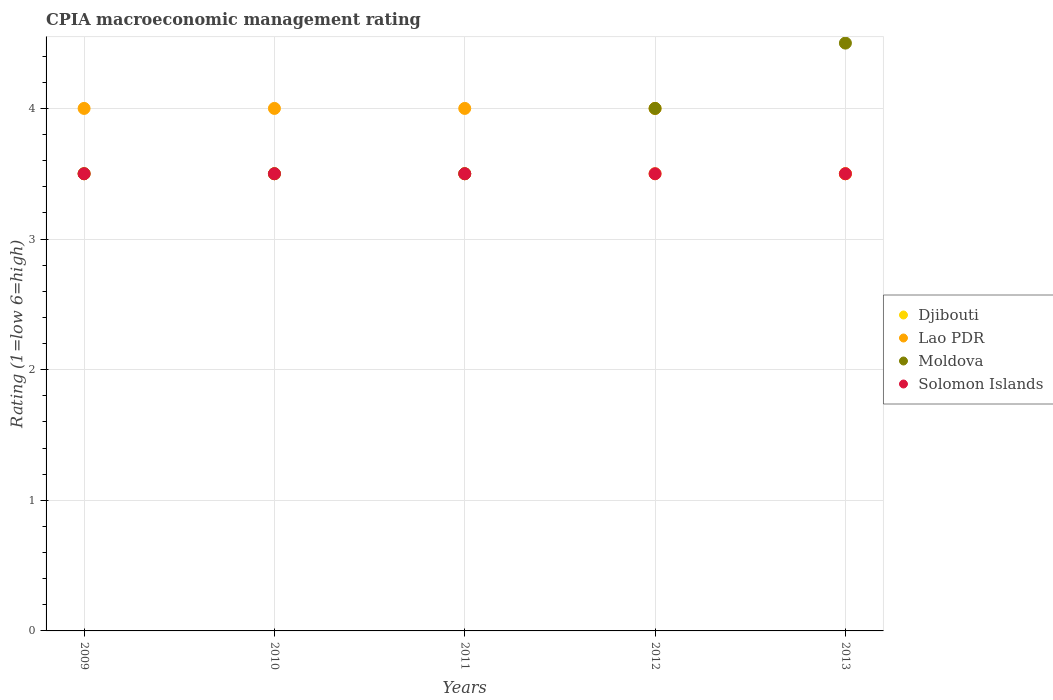Is the number of dotlines equal to the number of legend labels?
Provide a succinct answer. Yes. Across all years, what is the minimum CPIA rating in Solomon Islands?
Make the answer very short. 3.5. In which year was the CPIA rating in Djibouti maximum?
Give a very brief answer. 2009. What is the difference between the CPIA rating in Moldova in 2011 and the CPIA rating in Solomon Islands in 2012?
Make the answer very short. 0. What is the average CPIA rating in Solomon Islands per year?
Ensure brevity in your answer.  3.5. What is the ratio of the CPIA rating in Djibouti in 2012 to that in 2013?
Make the answer very short. 1. Is the CPIA rating in Lao PDR in 2009 less than that in 2013?
Make the answer very short. No. Is the difference between the CPIA rating in Djibouti in 2009 and 2010 greater than the difference between the CPIA rating in Moldova in 2009 and 2010?
Keep it short and to the point. No. What is the difference between the highest and the second highest CPIA rating in Djibouti?
Offer a very short reply. 0. Is it the case that in every year, the sum of the CPIA rating in Moldova and CPIA rating in Lao PDR  is greater than the sum of CPIA rating in Solomon Islands and CPIA rating in Djibouti?
Offer a terse response. Yes. Is it the case that in every year, the sum of the CPIA rating in Lao PDR and CPIA rating in Djibouti  is greater than the CPIA rating in Solomon Islands?
Give a very brief answer. Yes. How many dotlines are there?
Your response must be concise. 4. What is the difference between two consecutive major ticks on the Y-axis?
Provide a succinct answer. 1. Are the values on the major ticks of Y-axis written in scientific E-notation?
Offer a terse response. No. Where does the legend appear in the graph?
Offer a terse response. Center right. How many legend labels are there?
Provide a succinct answer. 4. How are the legend labels stacked?
Your answer should be very brief. Vertical. What is the title of the graph?
Provide a short and direct response. CPIA macroeconomic management rating. What is the label or title of the X-axis?
Ensure brevity in your answer.  Years. What is the label or title of the Y-axis?
Provide a short and direct response. Rating (1=low 6=high). What is the Rating (1=low 6=high) in Lao PDR in 2009?
Provide a succinct answer. 4. What is the Rating (1=low 6=high) in Solomon Islands in 2009?
Give a very brief answer. 3.5. What is the Rating (1=low 6=high) of Moldova in 2010?
Give a very brief answer. 3.5. What is the Rating (1=low 6=high) in Djibouti in 2011?
Provide a succinct answer. 3.5. What is the Rating (1=low 6=high) in Moldova in 2011?
Provide a short and direct response. 3.5. What is the Rating (1=low 6=high) of Solomon Islands in 2011?
Ensure brevity in your answer.  3.5. What is the Rating (1=low 6=high) of Djibouti in 2012?
Give a very brief answer. 3.5. What is the Rating (1=low 6=high) of Lao PDR in 2012?
Offer a very short reply. 4. What is the Rating (1=low 6=high) of Moldova in 2012?
Offer a very short reply. 4. What is the Rating (1=low 6=high) of Solomon Islands in 2012?
Keep it short and to the point. 3.5. What is the Rating (1=low 6=high) of Djibouti in 2013?
Your answer should be compact. 3.5. What is the Rating (1=low 6=high) of Solomon Islands in 2013?
Ensure brevity in your answer.  3.5. Across all years, what is the maximum Rating (1=low 6=high) in Djibouti?
Keep it short and to the point. 3.5. Across all years, what is the maximum Rating (1=low 6=high) of Lao PDR?
Provide a succinct answer. 4. Across all years, what is the maximum Rating (1=low 6=high) of Solomon Islands?
Provide a short and direct response. 3.5. Across all years, what is the minimum Rating (1=low 6=high) in Moldova?
Your answer should be compact. 3.5. Across all years, what is the minimum Rating (1=low 6=high) in Solomon Islands?
Offer a very short reply. 3.5. What is the total Rating (1=low 6=high) of Lao PDR in the graph?
Ensure brevity in your answer.  19.5. What is the total Rating (1=low 6=high) in Solomon Islands in the graph?
Give a very brief answer. 17.5. What is the difference between the Rating (1=low 6=high) of Djibouti in 2009 and that in 2010?
Your response must be concise. 0. What is the difference between the Rating (1=low 6=high) of Lao PDR in 2009 and that in 2010?
Provide a short and direct response. 0. What is the difference between the Rating (1=low 6=high) in Djibouti in 2009 and that in 2011?
Provide a succinct answer. 0. What is the difference between the Rating (1=low 6=high) in Lao PDR in 2009 and that in 2011?
Make the answer very short. 0. What is the difference between the Rating (1=low 6=high) of Moldova in 2009 and that in 2011?
Your answer should be very brief. 0. What is the difference between the Rating (1=low 6=high) in Moldova in 2009 and that in 2012?
Make the answer very short. -0.5. What is the difference between the Rating (1=low 6=high) in Solomon Islands in 2009 and that in 2012?
Offer a very short reply. 0. What is the difference between the Rating (1=low 6=high) in Djibouti in 2009 and that in 2013?
Provide a short and direct response. 0. What is the difference between the Rating (1=low 6=high) in Lao PDR in 2009 and that in 2013?
Offer a very short reply. 0.5. What is the difference between the Rating (1=low 6=high) of Moldova in 2009 and that in 2013?
Provide a succinct answer. -1. What is the difference between the Rating (1=low 6=high) of Solomon Islands in 2009 and that in 2013?
Offer a terse response. 0. What is the difference between the Rating (1=low 6=high) of Lao PDR in 2010 and that in 2011?
Provide a succinct answer. 0. What is the difference between the Rating (1=low 6=high) in Moldova in 2010 and that in 2012?
Ensure brevity in your answer.  -0.5. What is the difference between the Rating (1=low 6=high) in Djibouti in 2010 and that in 2013?
Make the answer very short. 0. What is the difference between the Rating (1=low 6=high) in Lao PDR in 2010 and that in 2013?
Keep it short and to the point. 0.5. What is the difference between the Rating (1=low 6=high) in Moldova in 2011 and that in 2012?
Give a very brief answer. -0.5. What is the difference between the Rating (1=low 6=high) in Lao PDR in 2011 and that in 2013?
Your response must be concise. 0.5. What is the difference between the Rating (1=low 6=high) of Moldova in 2012 and that in 2013?
Your response must be concise. -0.5. What is the difference between the Rating (1=low 6=high) in Solomon Islands in 2012 and that in 2013?
Keep it short and to the point. 0. What is the difference between the Rating (1=low 6=high) in Djibouti in 2009 and the Rating (1=low 6=high) in Moldova in 2010?
Make the answer very short. 0. What is the difference between the Rating (1=low 6=high) in Djibouti in 2009 and the Rating (1=low 6=high) in Lao PDR in 2011?
Your answer should be very brief. -0.5. What is the difference between the Rating (1=low 6=high) of Djibouti in 2009 and the Rating (1=low 6=high) of Moldova in 2011?
Give a very brief answer. 0. What is the difference between the Rating (1=low 6=high) of Lao PDR in 2009 and the Rating (1=low 6=high) of Moldova in 2011?
Provide a short and direct response. 0.5. What is the difference between the Rating (1=low 6=high) of Lao PDR in 2009 and the Rating (1=low 6=high) of Solomon Islands in 2011?
Give a very brief answer. 0.5. What is the difference between the Rating (1=low 6=high) in Moldova in 2009 and the Rating (1=low 6=high) in Solomon Islands in 2011?
Give a very brief answer. 0. What is the difference between the Rating (1=low 6=high) of Djibouti in 2009 and the Rating (1=low 6=high) of Moldova in 2012?
Make the answer very short. -0.5. What is the difference between the Rating (1=low 6=high) of Djibouti in 2009 and the Rating (1=low 6=high) of Solomon Islands in 2012?
Provide a short and direct response. 0. What is the difference between the Rating (1=low 6=high) of Lao PDR in 2009 and the Rating (1=low 6=high) of Moldova in 2012?
Your response must be concise. 0. What is the difference between the Rating (1=low 6=high) of Djibouti in 2009 and the Rating (1=low 6=high) of Moldova in 2013?
Your answer should be compact. -1. What is the difference between the Rating (1=low 6=high) of Lao PDR in 2009 and the Rating (1=low 6=high) of Moldova in 2013?
Give a very brief answer. -0.5. What is the difference between the Rating (1=low 6=high) in Djibouti in 2010 and the Rating (1=low 6=high) in Lao PDR in 2011?
Your answer should be compact. -0.5. What is the difference between the Rating (1=low 6=high) in Djibouti in 2010 and the Rating (1=low 6=high) in Moldova in 2011?
Ensure brevity in your answer.  0. What is the difference between the Rating (1=low 6=high) of Djibouti in 2010 and the Rating (1=low 6=high) of Solomon Islands in 2011?
Offer a terse response. 0. What is the difference between the Rating (1=low 6=high) in Moldova in 2010 and the Rating (1=low 6=high) in Solomon Islands in 2011?
Offer a terse response. 0. What is the difference between the Rating (1=low 6=high) in Djibouti in 2010 and the Rating (1=low 6=high) in Moldova in 2012?
Your response must be concise. -0.5. What is the difference between the Rating (1=low 6=high) of Lao PDR in 2010 and the Rating (1=low 6=high) of Solomon Islands in 2012?
Offer a terse response. 0.5. What is the difference between the Rating (1=low 6=high) of Djibouti in 2010 and the Rating (1=low 6=high) of Solomon Islands in 2013?
Make the answer very short. 0. What is the difference between the Rating (1=low 6=high) of Moldova in 2010 and the Rating (1=low 6=high) of Solomon Islands in 2013?
Provide a short and direct response. 0. What is the difference between the Rating (1=low 6=high) of Djibouti in 2011 and the Rating (1=low 6=high) of Lao PDR in 2012?
Provide a succinct answer. -0.5. What is the difference between the Rating (1=low 6=high) in Lao PDR in 2011 and the Rating (1=low 6=high) in Moldova in 2012?
Ensure brevity in your answer.  0. What is the difference between the Rating (1=low 6=high) in Lao PDR in 2011 and the Rating (1=low 6=high) in Solomon Islands in 2012?
Your response must be concise. 0.5. What is the difference between the Rating (1=low 6=high) of Djibouti in 2011 and the Rating (1=low 6=high) of Lao PDR in 2013?
Keep it short and to the point. 0. What is the difference between the Rating (1=low 6=high) of Djibouti in 2011 and the Rating (1=low 6=high) of Moldova in 2013?
Your answer should be compact. -1. What is the difference between the Rating (1=low 6=high) of Djibouti in 2011 and the Rating (1=low 6=high) of Solomon Islands in 2013?
Ensure brevity in your answer.  0. What is the difference between the Rating (1=low 6=high) in Lao PDR in 2011 and the Rating (1=low 6=high) in Moldova in 2013?
Offer a terse response. -0.5. What is the difference between the Rating (1=low 6=high) of Djibouti in 2012 and the Rating (1=low 6=high) of Solomon Islands in 2013?
Keep it short and to the point. 0. What is the average Rating (1=low 6=high) of Djibouti per year?
Provide a short and direct response. 3.5. What is the average Rating (1=low 6=high) in Lao PDR per year?
Provide a short and direct response. 3.9. What is the average Rating (1=low 6=high) in Moldova per year?
Offer a very short reply. 3.8. In the year 2009, what is the difference between the Rating (1=low 6=high) of Djibouti and Rating (1=low 6=high) of Solomon Islands?
Provide a succinct answer. 0. In the year 2009, what is the difference between the Rating (1=low 6=high) of Lao PDR and Rating (1=low 6=high) of Solomon Islands?
Keep it short and to the point. 0.5. In the year 2009, what is the difference between the Rating (1=low 6=high) in Moldova and Rating (1=low 6=high) in Solomon Islands?
Make the answer very short. 0. In the year 2010, what is the difference between the Rating (1=low 6=high) of Djibouti and Rating (1=low 6=high) of Lao PDR?
Offer a very short reply. -0.5. In the year 2010, what is the difference between the Rating (1=low 6=high) in Djibouti and Rating (1=low 6=high) in Solomon Islands?
Provide a short and direct response. 0. In the year 2010, what is the difference between the Rating (1=low 6=high) in Lao PDR and Rating (1=low 6=high) in Moldova?
Offer a terse response. 0.5. In the year 2011, what is the difference between the Rating (1=low 6=high) in Djibouti and Rating (1=low 6=high) in Moldova?
Provide a succinct answer. 0. In the year 2011, what is the difference between the Rating (1=low 6=high) of Lao PDR and Rating (1=low 6=high) of Solomon Islands?
Provide a short and direct response. 0.5. In the year 2012, what is the difference between the Rating (1=low 6=high) of Djibouti and Rating (1=low 6=high) of Moldova?
Your answer should be very brief. -0.5. In the year 2012, what is the difference between the Rating (1=low 6=high) in Lao PDR and Rating (1=low 6=high) in Solomon Islands?
Your response must be concise. 0.5. In the year 2013, what is the difference between the Rating (1=low 6=high) in Djibouti and Rating (1=low 6=high) in Moldova?
Keep it short and to the point. -1. In the year 2013, what is the difference between the Rating (1=low 6=high) in Djibouti and Rating (1=low 6=high) in Solomon Islands?
Make the answer very short. 0. In the year 2013, what is the difference between the Rating (1=low 6=high) in Lao PDR and Rating (1=low 6=high) in Solomon Islands?
Offer a very short reply. 0. What is the ratio of the Rating (1=low 6=high) in Djibouti in 2009 to that in 2010?
Provide a short and direct response. 1. What is the ratio of the Rating (1=low 6=high) in Djibouti in 2009 to that in 2012?
Make the answer very short. 1. What is the ratio of the Rating (1=low 6=high) of Lao PDR in 2009 to that in 2012?
Your response must be concise. 1. What is the ratio of the Rating (1=low 6=high) of Moldova in 2009 to that in 2012?
Give a very brief answer. 0.88. What is the ratio of the Rating (1=low 6=high) of Djibouti in 2009 to that in 2013?
Keep it short and to the point. 1. What is the ratio of the Rating (1=low 6=high) of Lao PDR in 2009 to that in 2013?
Your answer should be compact. 1.14. What is the ratio of the Rating (1=low 6=high) in Solomon Islands in 2009 to that in 2013?
Provide a succinct answer. 1. What is the ratio of the Rating (1=low 6=high) in Djibouti in 2010 to that in 2011?
Your response must be concise. 1. What is the ratio of the Rating (1=low 6=high) in Lao PDR in 2010 to that in 2012?
Give a very brief answer. 1. What is the ratio of the Rating (1=low 6=high) of Djibouti in 2010 to that in 2013?
Provide a succinct answer. 1. What is the ratio of the Rating (1=low 6=high) in Lao PDR in 2010 to that in 2013?
Make the answer very short. 1.14. What is the ratio of the Rating (1=low 6=high) of Moldova in 2010 to that in 2013?
Offer a very short reply. 0.78. What is the ratio of the Rating (1=low 6=high) of Djibouti in 2011 to that in 2012?
Provide a succinct answer. 1. What is the ratio of the Rating (1=low 6=high) in Lao PDR in 2011 to that in 2012?
Your answer should be very brief. 1. What is the ratio of the Rating (1=low 6=high) of Moldova in 2011 to that in 2012?
Offer a very short reply. 0.88. What is the ratio of the Rating (1=low 6=high) of Solomon Islands in 2011 to that in 2012?
Give a very brief answer. 1. What is the ratio of the Rating (1=low 6=high) in Lao PDR in 2011 to that in 2013?
Offer a very short reply. 1.14. What is the ratio of the Rating (1=low 6=high) of Solomon Islands in 2011 to that in 2013?
Ensure brevity in your answer.  1. What is the ratio of the Rating (1=low 6=high) of Djibouti in 2012 to that in 2013?
Your response must be concise. 1. What is the difference between the highest and the second highest Rating (1=low 6=high) in Djibouti?
Make the answer very short. 0. What is the difference between the highest and the second highest Rating (1=low 6=high) in Lao PDR?
Ensure brevity in your answer.  0. What is the difference between the highest and the second highest Rating (1=low 6=high) in Moldova?
Provide a short and direct response. 0.5. What is the difference between the highest and the second highest Rating (1=low 6=high) of Solomon Islands?
Your response must be concise. 0. What is the difference between the highest and the lowest Rating (1=low 6=high) of Lao PDR?
Give a very brief answer. 0.5. 